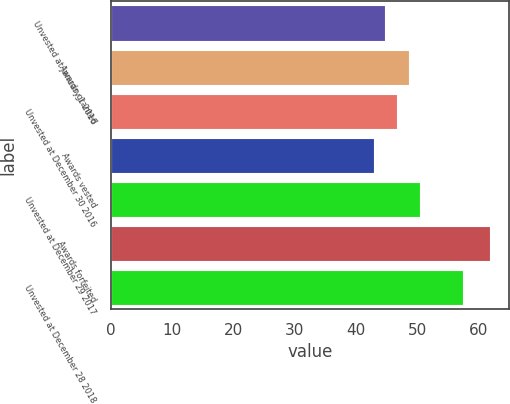Convert chart to OTSL. <chart><loc_0><loc_0><loc_500><loc_500><bar_chart><fcel>Unvested at January 1 2016<fcel>Awards granted<fcel>Unvested at December 30 2016<fcel>Awards vested<fcel>Unvested at December 29 2017<fcel>Awards forfeited<fcel>Unvested at December 28 2018<nl><fcel>44.75<fcel>48.55<fcel>46.65<fcel>42.85<fcel>50.45<fcel>61.81<fcel>57.36<nl></chart> 